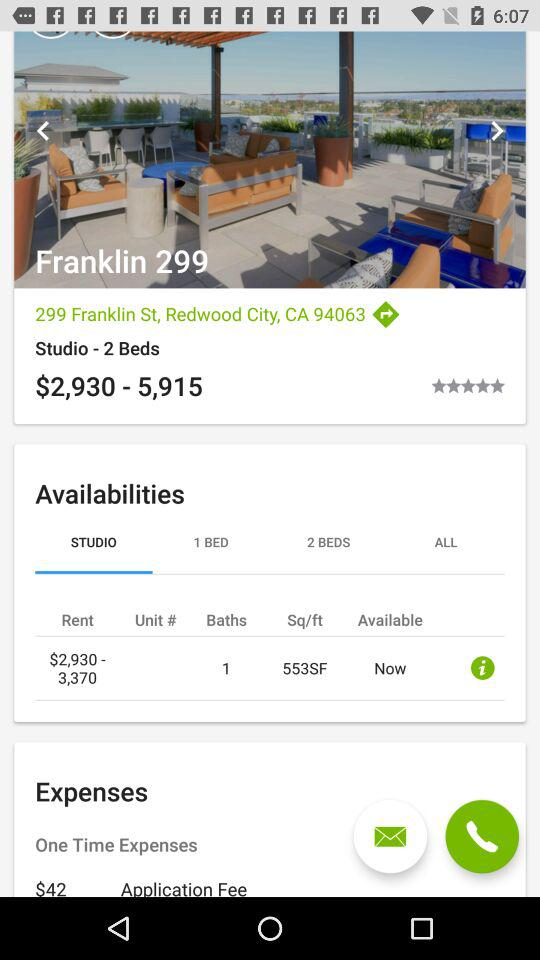What is the location of "Franklin 299"? The location of "Franklin 299" is 299 Franklin St., Redwood City, CA 94063. 